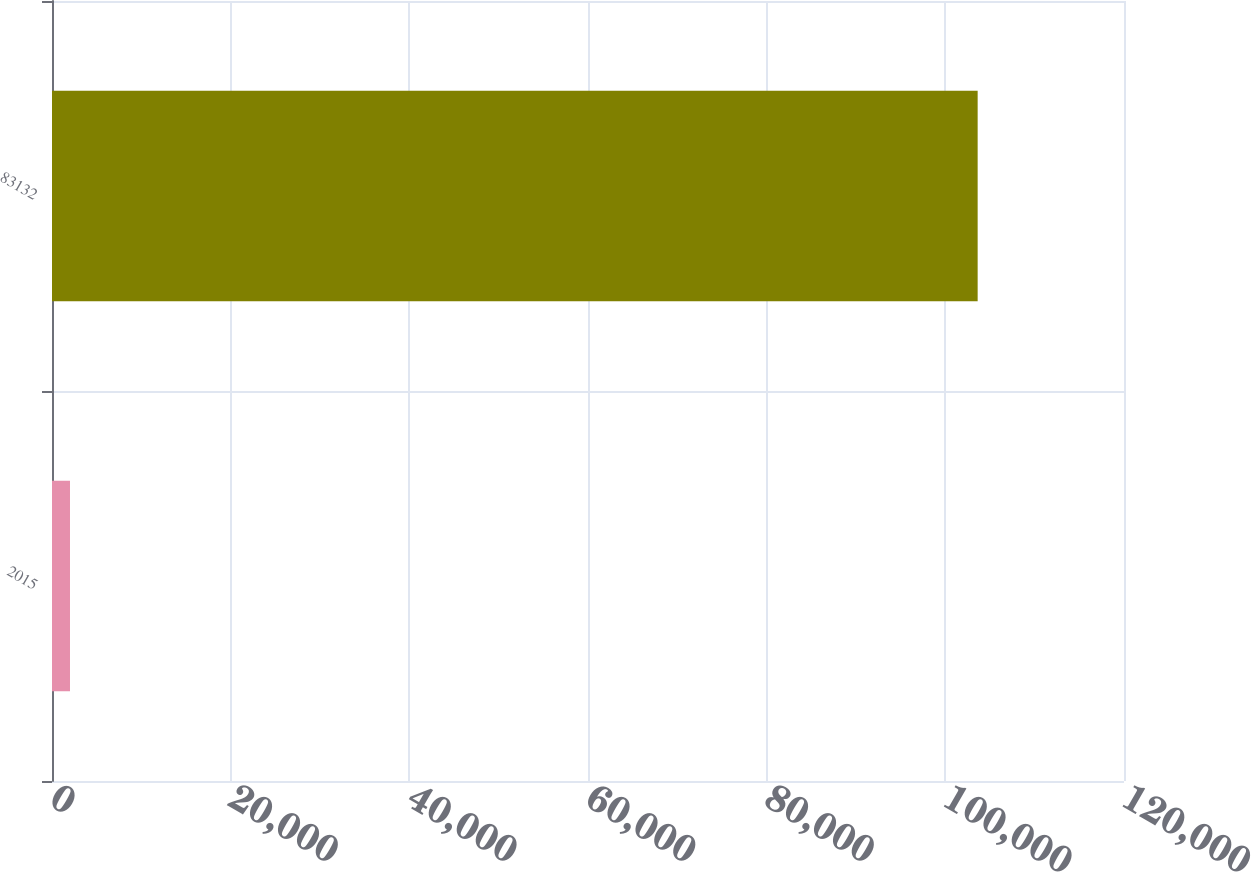Convert chart. <chart><loc_0><loc_0><loc_500><loc_500><bar_chart><fcel>2015<fcel>83132<nl><fcel>2014<fcel>103618<nl></chart> 